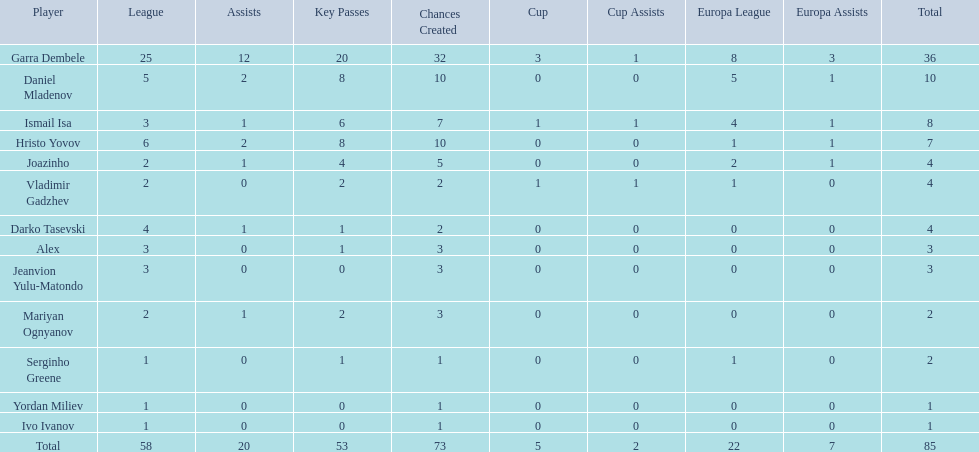What players did not score in all 3 competitions? Daniel Mladenov, Hristo Yovov, Joazinho, Darko Tasevski, Alex, Jeanvion Yulu-Matondo, Mariyan Ognyanov, Serginho Greene, Yordan Miliev, Ivo Ivanov. Which of those did not have total more then 5? Darko Tasevski, Alex, Jeanvion Yulu-Matondo, Mariyan Ognyanov, Serginho Greene, Yordan Miliev, Ivo Ivanov. Which ones scored more then 1 total? Darko Tasevski, Alex, Jeanvion Yulu-Matondo, Mariyan Ognyanov. Which of these player had the lease league points? Mariyan Ognyanov. 